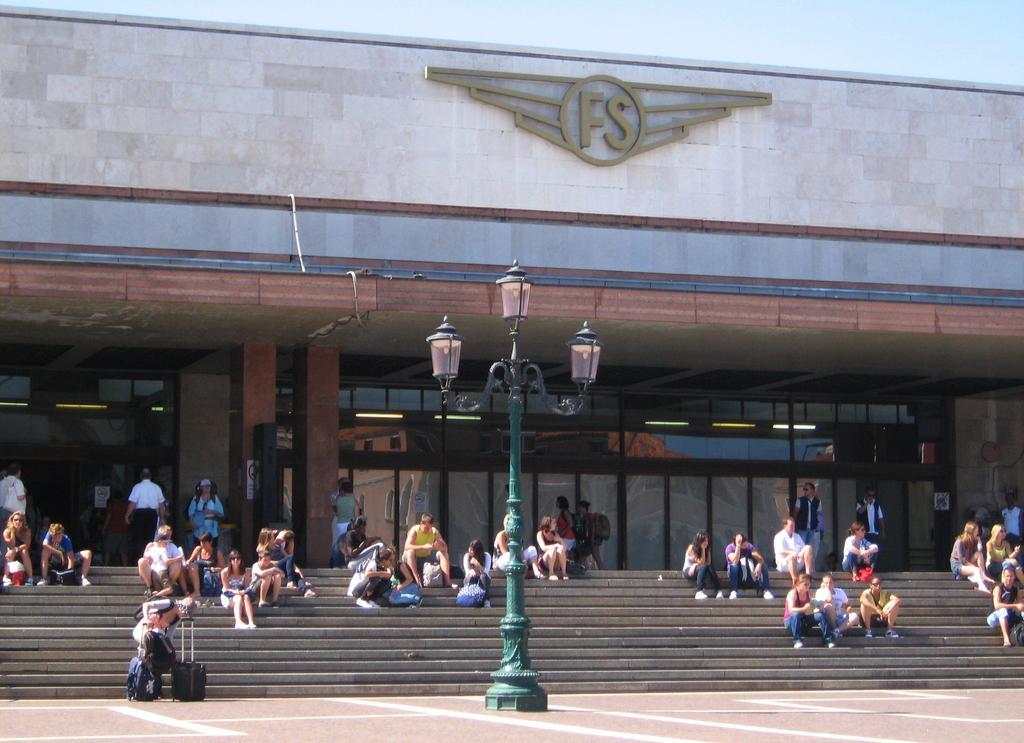Describe this image in one or two sentences. In the foreground of the picture it is pavement and there is a street light. In the center of the picture there are people sitting on the staircase. In the background it is a building we can see lights, windows and door. At the top it is sky. On the building there is text. 